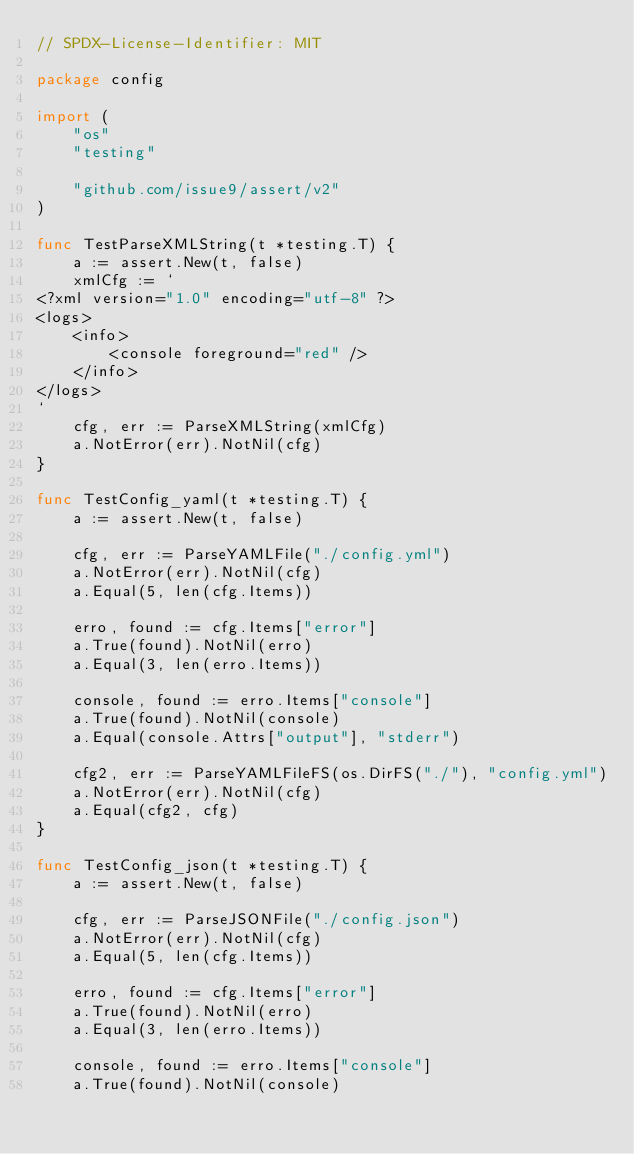<code> <loc_0><loc_0><loc_500><loc_500><_Go_>// SPDX-License-Identifier: MIT

package config

import (
	"os"
	"testing"

	"github.com/issue9/assert/v2"
)

func TestParseXMLString(t *testing.T) {
	a := assert.New(t, false)
	xmlCfg := `
<?xml version="1.0" encoding="utf-8" ?>
<logs>
    <info>
		<console foreground="red" />
	</info>
</logs>
`
	cfg, err := ParseXMLString(xmlCfg)
	a.NotError(err).NotNil(cfg)
}

func TestConfig_yaml(t *testing.T) {
	a := assert.New(t, false)

	cfg, err := ParseYAMLFile("./config.yml")
	a.NotError(err).NotNil(cfg)
	a.Equal(5, len(cfg.Items))

	erro, found := cfg.Items["error"]
	a.True(found).NotNil(erro)
	a.Equal(3, len(erro.Items))

	console, found := erro.Items["console"]
	a.True(found).NotNil(console)
	a.Equal(console.Attrs["output"], "stderr")

	cfg2, err := ParseYAMLFileFS(os.DirFS("./"), "config.yml")
	a.NotError(err).NotNil(cfg)
	a.Equal(cfg2, cfg)
}

func TestConfig_json(t *testing.T) {
	a := assert.New(t, false)

	cfg, err := ParseJSONFile("./config.json")
	a.NotError(err).NotNil(cfg)
	a.Equal(5, len(cfg.Items))

	erro, found := cfg.Items["error"]
	a.True(found).NotNil(erro)
	a.Equal(3, len(erro.Items))

	console, found := erro.Items["console"]
	a.True(found).NotNil(console)</code> 